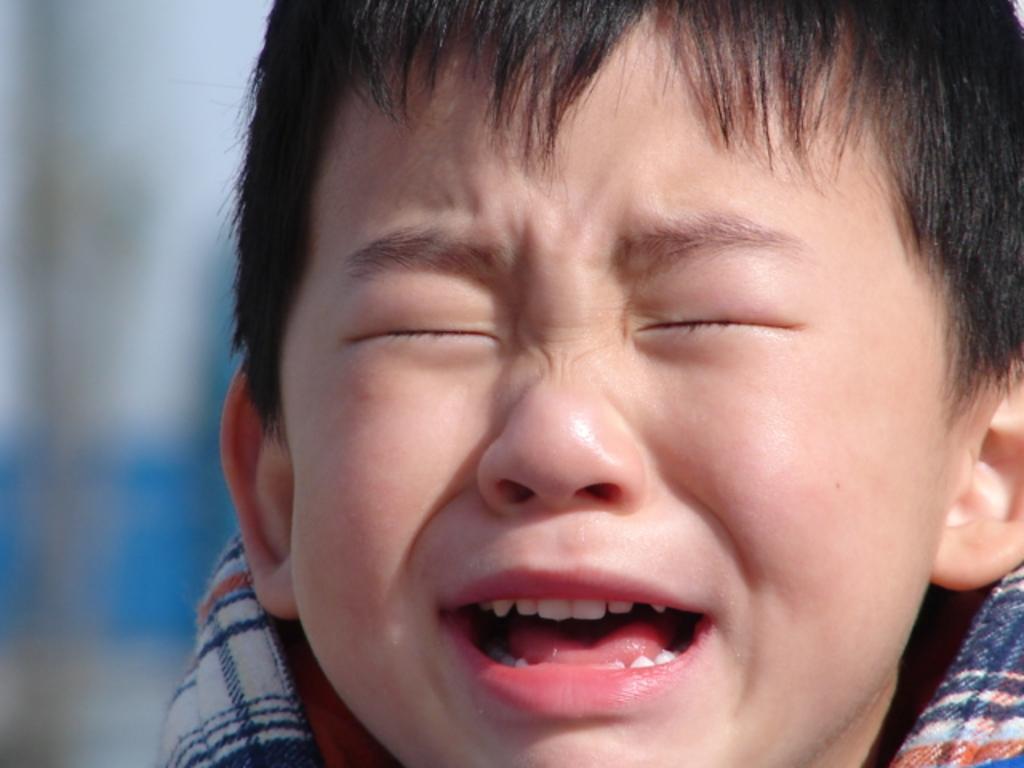Please provide a concise description of this image. In this picture we can see a small kid crying with his eyes closed. 